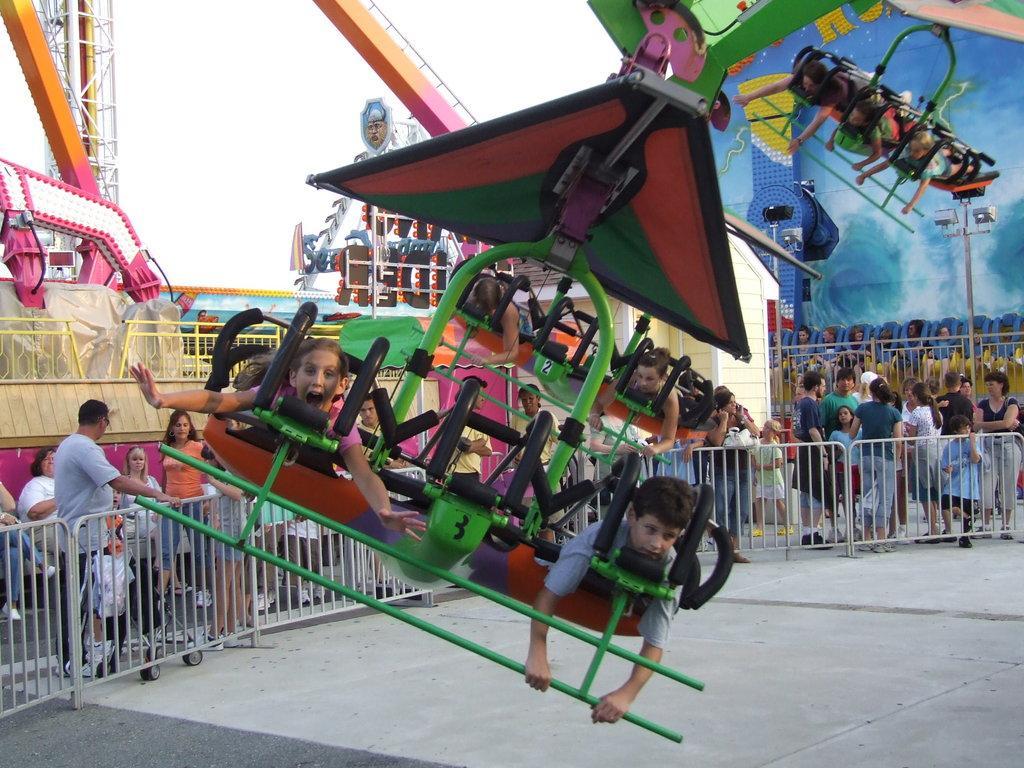Could you give a brief overview of what you see in this image? In this picture I can see some children's are playing, side few people are standing near fencing and watching. 